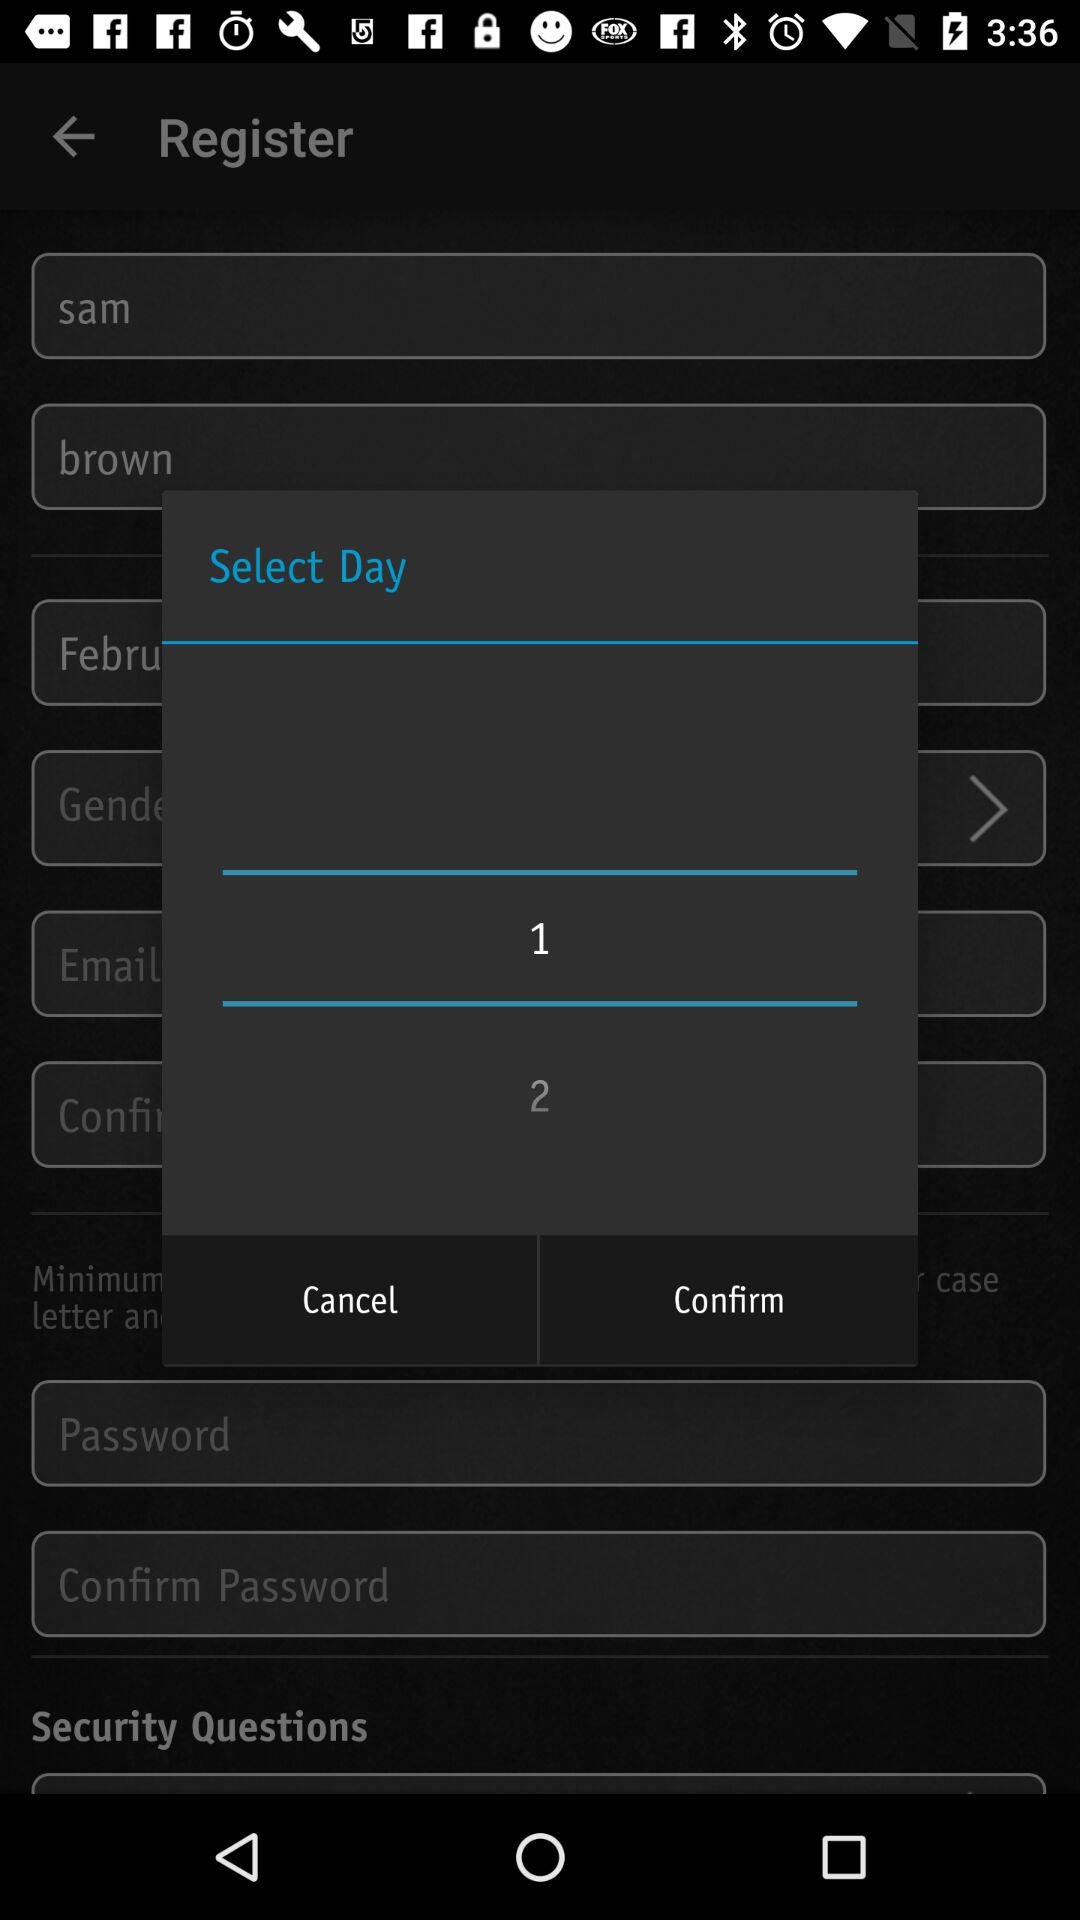What is the selected day? The selected day is 1. 